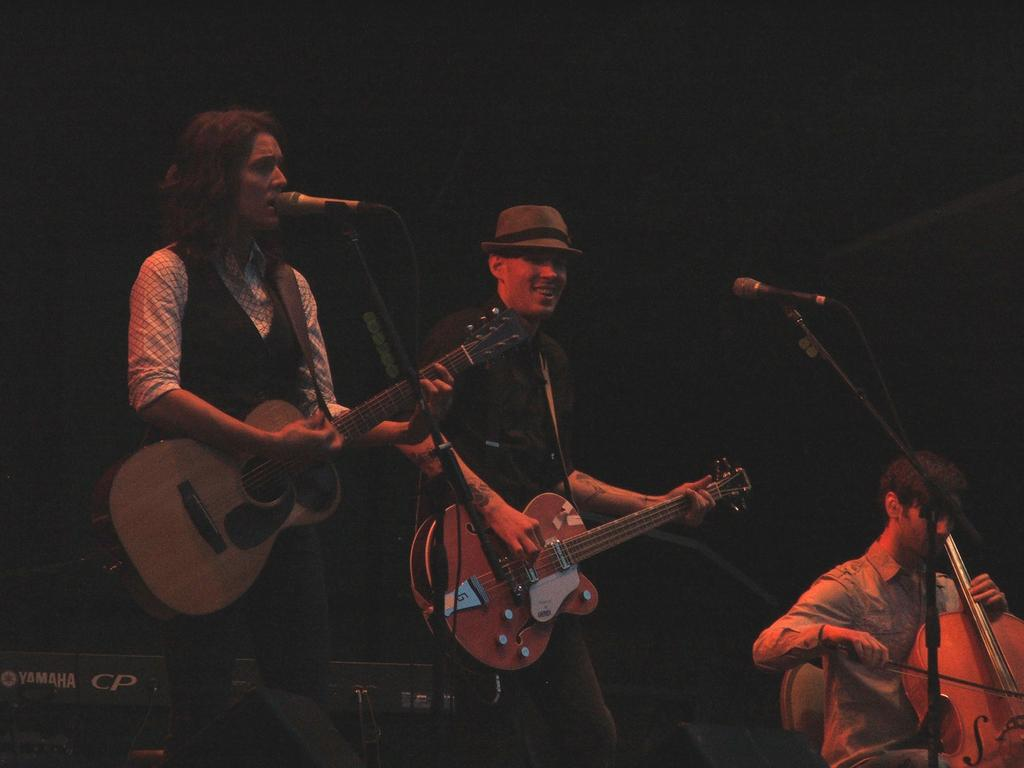How many people are in the image? There are three people in the image. What are the people doing in the image? The people are performing in the image. What specific activity are the people engaged in? The people are playing musical instruments and one person is singing. What type of stem can be seen growing from the person's head in the image? There is no stem growing from anyone's head in the image. What attraction is visible in the background of the image? There is no attraction visible in the image; it only features the three people performing. 